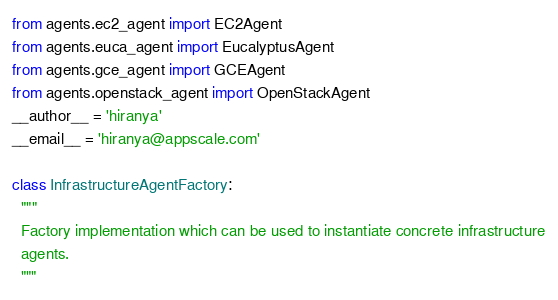Convert code to text. <code><loc_0><loc_0><loc_500><loc_500><_Python_>from agents.ec2_agent import EC2Agent
from agents.euca_agent import EucalyptusAgent
from agents.gce_agent import GCEAgent
from agents.openstack_agent import OpenStackAgent
__author__ = 'hiranya'
__email__ = 'hiranya@appscale.com'

class InfrastructureAgentFactory:
  """
  Factory implementation which can be used to instantiate concrete infrastructure
  agents.
  """
</code> 